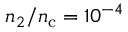<formula> <loc_0><loc_0><loc_500><loc_500>n _ { 2 } / n _ { c } = 1 0 ^ { - 4 }</formula> 